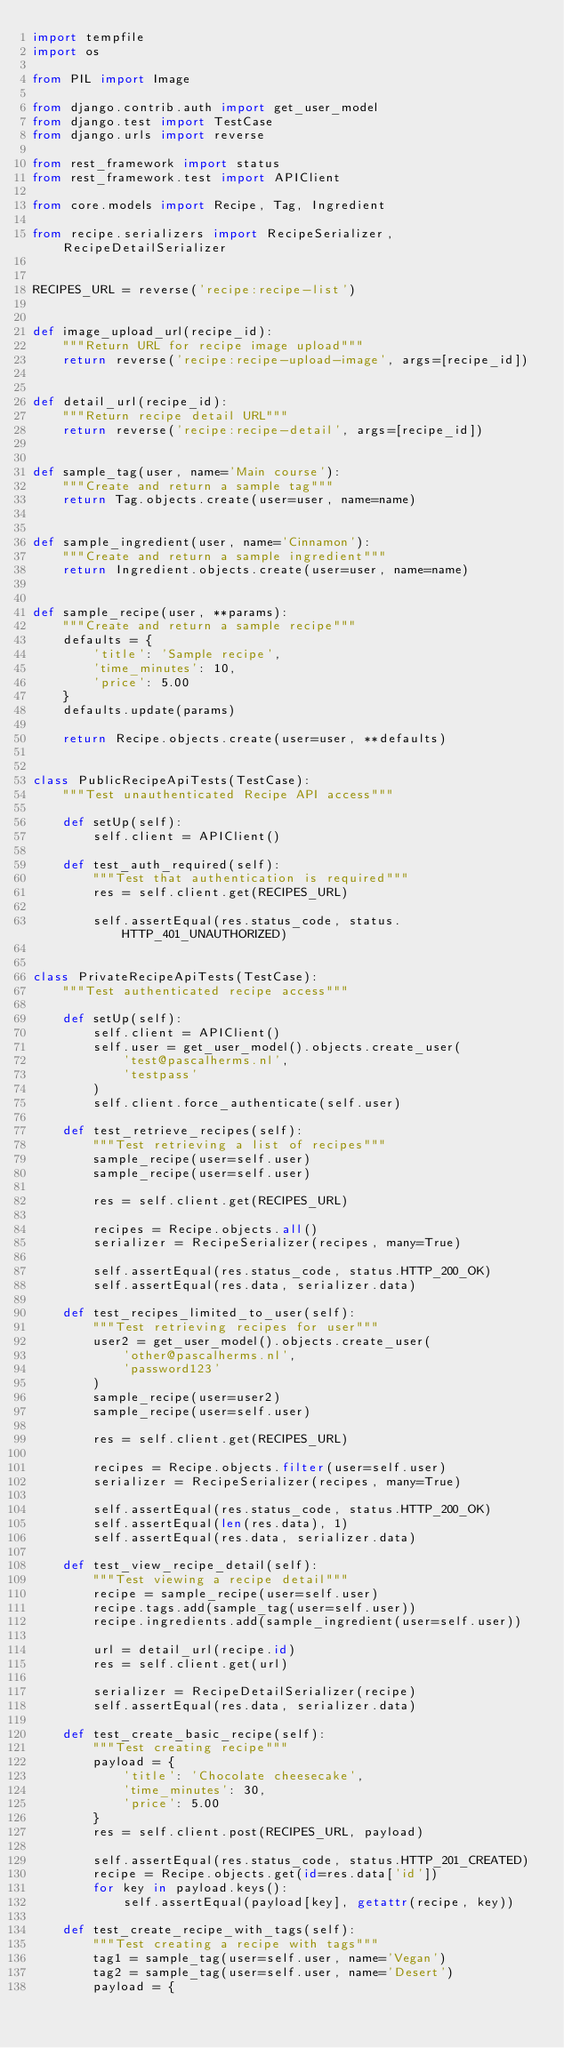<code> <loc_0><loc_0><loc_500><loc_500><_Python_>import tempfile
import os

from PIL import Image

from django.contrib.auth import get_user_model
from django.test import TestCase
from django.urls import reverse

from rest_framework import status
from rest_framework.test import APIClient

from core.models import Recipe, Tag, Ingredient

from recipe.serializers import RecipeSerializer, RecipeDetailSerializer


RECIPES_URL = reverse('recipe:recipe-list')


def image_upload_url(recipe_id):
    """Return URL for recipe image upload"""
    return reverse('recipe:recipe-upload-image', args=[recipe_id])


def detail_url(recipe_id):
    """Return recipe detail URL"""
    return reverse('recipe:recipe-detail', args=[recipe_id])


def sample_tag(user, name='Main course'):
    """Create and return a sample tag"""
    return Tag.objects.create(user=user, name=name)


def sample_ingredient(user, name='Cinnamon'):
    """Create and return a sample ingredient"""
    return Ingredient.objects.create(user=user, name=name)


def sample_recipe(user, **params):
    """Create and return a sample recipe"""
    defaults = {
        'title': 'Sample recipe',
        'time_minutes': 10,
        'price': 5.00
    }
    defaults.update(params)

    return Recipe.objects.create(user=user, **defaults)


class PublicRecipeApiTests(TestCase):
    """Test unauthenticated Recipe API access"""

    def setUp(self):
        self.client = APIClient()

    def test_auth_required(self):
        """Test that authentication is required"""
        res = self.client.get(RECIPES_URL)

        self.assertEqual(res.status_code, status.HTTP_401_UNAUTHORIZED)


class PrivateRecipeApiTests(TestCase):
    """Test authenticated recipe access"""

    def setUp(self):
        self.client = APIClient()
        self.user = get_user_model().objects.create_user(
            'test@pascalherms.nl',
            'testpass'
        )
        self.client.force_authenticate(self.user)

    def test_retrieve_recipes(self):
        """Test retrieving a list of recipes"""
        sample_recipe(user=self.user)
        sample_recipe(user=self.user)

        res = self.client.get(RECIPES_URL)

        recipes = Recipe.objects.all()
        serializer = RecipeSerializer(recipes, many=True)

        self.assertEqual(res.status_code, status.HTTP_200_OK)
        self.assertEqual(res.data, serializer.data)

    def test_recipes_limited_to_user(self):
        """Test retrieving recipes for user"""
        user2 = get_user_model().objects.create_user(
            'other@pascalherms.nl',
            'password123'
        )
        sample_recipe(user=user2)
        sample_recipe(user=self.user)

        res = self.client.get(RECIPES_URL)

        recipes = Recipe.objects.filter(user=self.user)
        serializer = RecipeSerializer(recipes, many=True)

        self.assertEqual(res.status_code, status.HTTP_200_OK)
        self.assertEqual(len(res.data), 1)
        self.assertEqual(res.data, serializer.data)

    def test_view_recipe_detail(self):
        """Test viewing a recipe detail"""
        recipe = sample_recipe(user=self.user)
        recipe.tags.add(sample_tag(user=self.user))
        recipe.ingredients.add(sample_ingredient(user=self.user))

        url = detail_url(recipe.id)
        res = self.client.get(url)

        serializer = RecipeDetailSerializer(recipe)
        self.assertEqual(res.data, serializer.data)

    def test_create_basic_recipe(self):
        """Test creating recipe"""
        payload = {
            'title': 'Chocolate cheesecake',
            'time_minutes': 30,
            'price': 5.00
        }
        res = self.client.post(RECIPES_URL, payload)

        self.assertEqual(res.status_code, status.HTTP_201_CREATED)
        recipe = Recipe.objects.get(id=res.data['id'])
        for key in payload.keys():
            self.assertEqual(payload[key], getattr(recipe, key))

    def test_create_recipe_with_tags(self):
        """Test creating a recipe with tags"""
        tag1 = sample_tag(user=self.user, name='Vegan')
        tag2 = sample_tag(user=self.user, name='Desert')
        payload = {</code> 